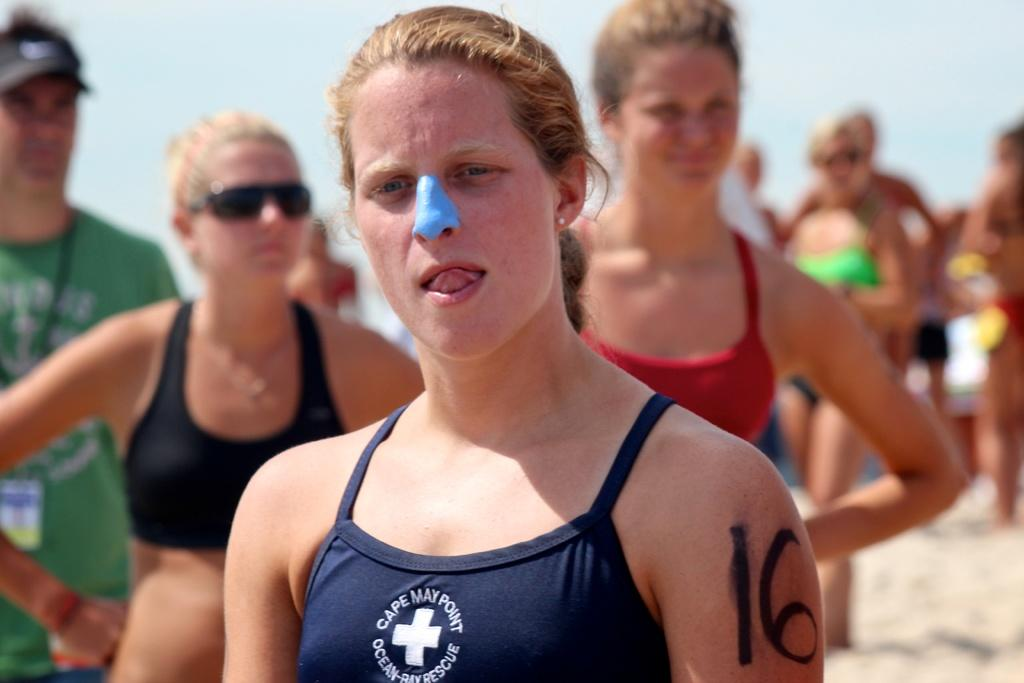<image>
Provide a brief description of the given image. A picture of a woman with the number 16 on her arm. 